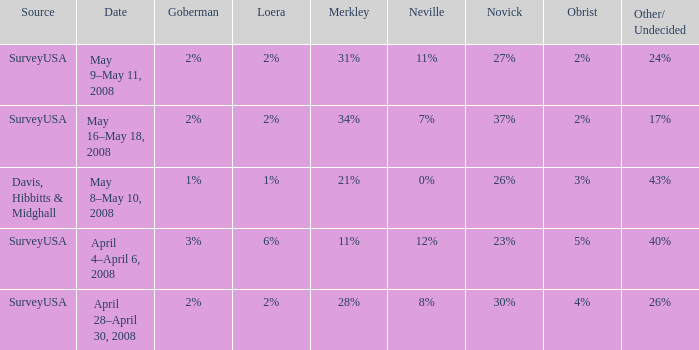Which Date has a Novick of 26%? May 8–May 10, 2008. 